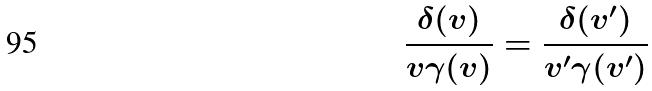<formula> <loc_0><loc_0><loc_500><loc_500>\frac { \delta ( v ) } { v \gamma ( v ) } = \frac { \delta ( v ^ { \prime } ) } { v ^ { \prime } \gamma ( v ^ { \prime } ) }</formula> 